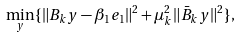Convert formula to latex. <formula><loc_0><loc_0><loc_500><loc_500>\min _ { y } \{ \| B _ { k } y - \beta _ { 1 } e _ { 1 } \| ^ { 2 } + \mu _ { k } ^ { 2 } \| \bar { B } _ { k } y \| ^ { 2 } \} ,</formula> 